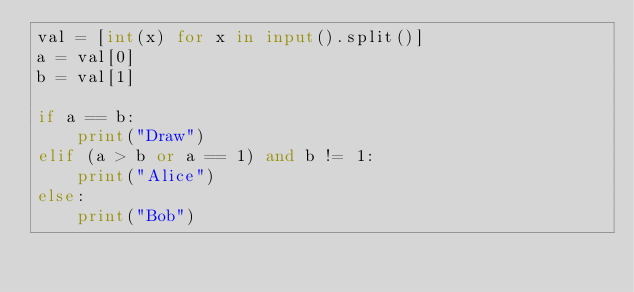Convert code to text. <code><loc_0><loc_0><loc_500><loc_500><_Python_>val = [int(x) for x in input().split()]
a = val[0]
b = val[1]

if a == b:
    print("Draw")
elif (a > b or a == 1) and b != 1:
    print("Alice")
else:
    print("Bob")
</code> 